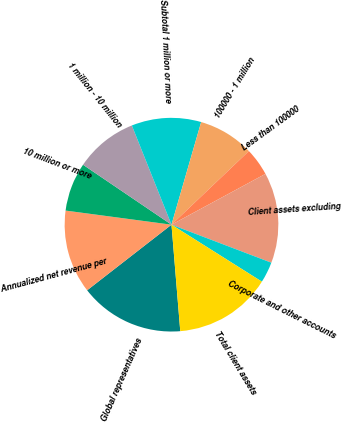<chart> <loc_0><loc_0><loc_500><loc_500><pie_chart><fcel>Global representatives<fcel>Annualized net revenue per<fcel>10 million or more<fcel>1 million - 10 million<fcel>Subtotal 1 million or more<fcel>100000 - 1 million<fcel>Less than 100000<fcel>Client assets excluding<fcel>Corporate and other accounts<fcel>Total client assets<nl><fcel>15.79%<fcel>12.63%<fcel>7.37%<fcel>9.47%<fcel>10.53%<fcel>8.42%<fcel>4.21%<fcel>13.68%<fcel>3.16%<fcel>14.74%<nl></chart> 